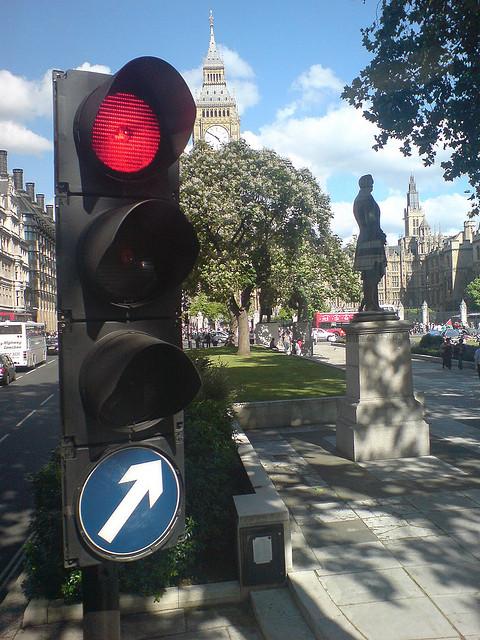Do you stop or go?
Concise answer only. Stop. How many white arrows?
Write a very short answer. 1. What time is the clock in the background?
Quick response, please. 4:50. 